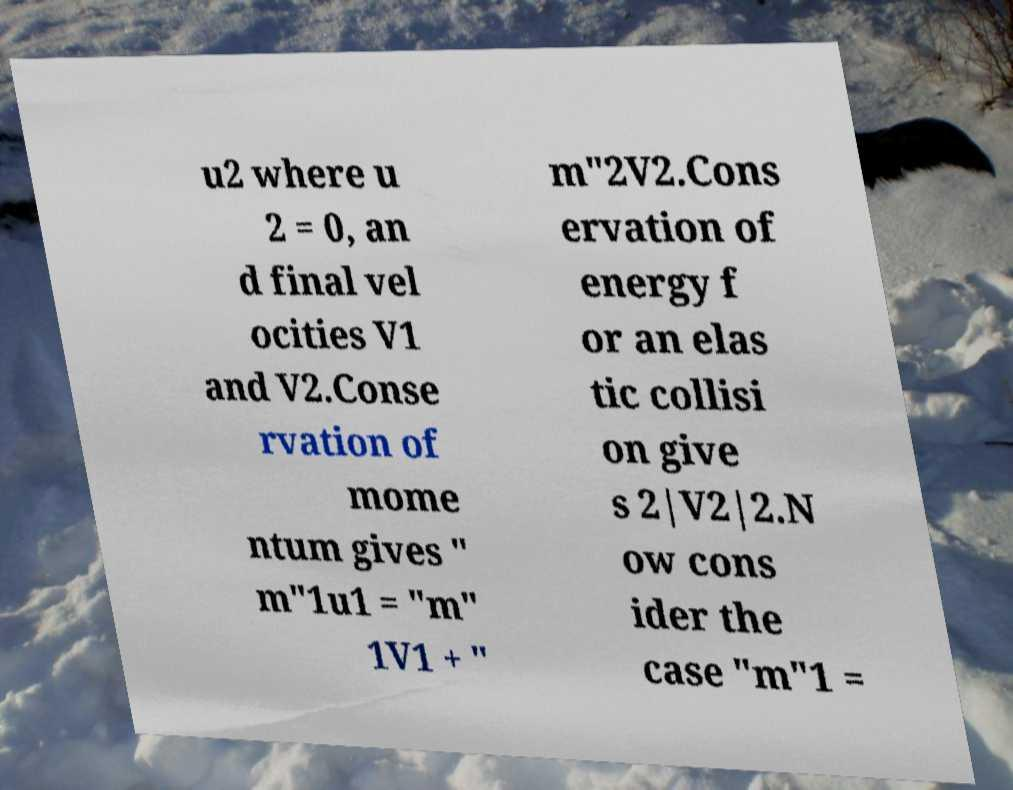What messages or text are displayed in this image? I need them in a readable, typed format. u2 where u 2 = 0, an d final vel ocities V1 and V2.Conse rvation of mome ntum gives " m"1u1 = "m" 1V1 + " m"2V2.Cons ervation of energy f or an elas tic collisi on give s 2|V2|2.N ow cons ider the case "m"1 = 